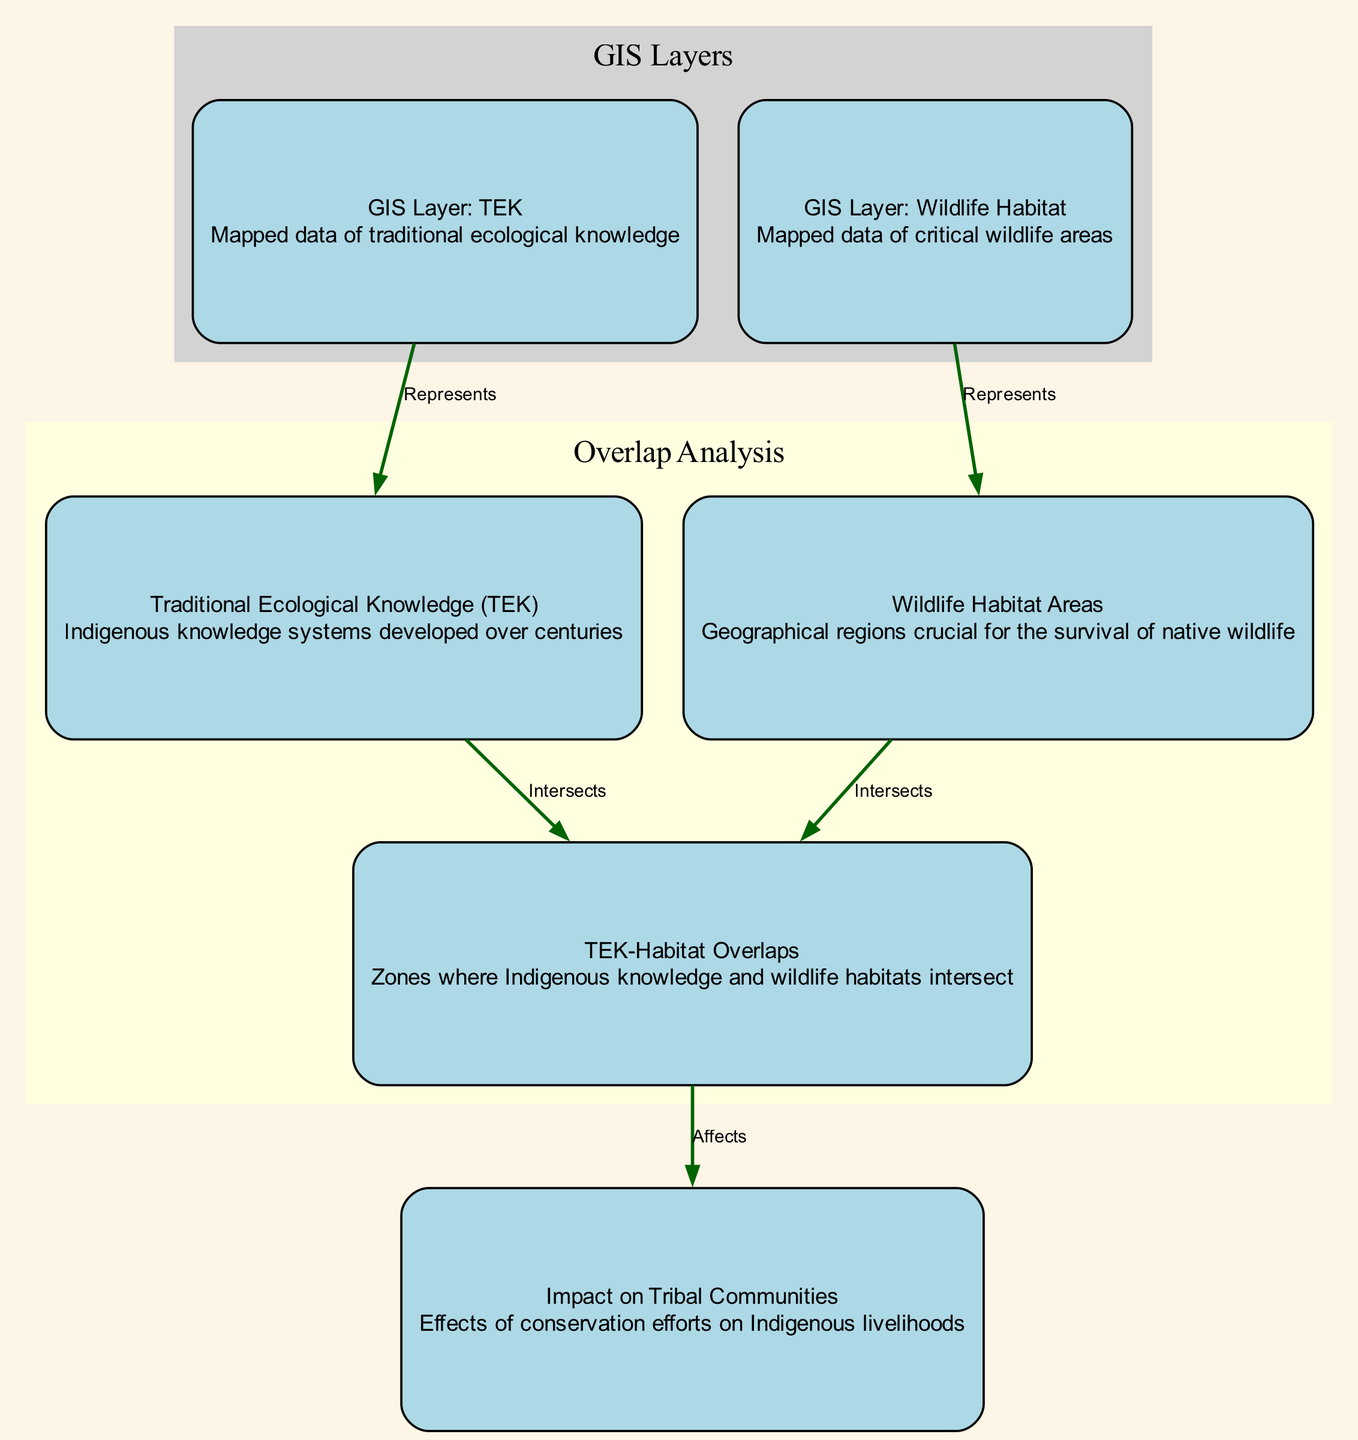What is the total number of nodes in the diagram? The diagram has six distinct nodes: TEK, Wildlife Habitat Areas, TEK-Habitat Overlaps, GIS Layer: TEK, GIS Layer: Wildlife Habitat, and Impact on Tribal Communities. Therefore, the total number of nodes is six.
Answer: 6 What does the TEK node represent? The TEK node represents Traditional Ecological Knowledge, defined as Indigenous knowledge systems developed over centuries.
Answer: Traditional Ecological Knowledge (TEK) Which two nodes intersect to form the TEK-Habitat Overlaps? The two nodes that intersect to form the TEK-Habitat Overlaps are Traditional Ecological Knowledge (TEK) and Wildlife Habitat Areas.
Answer: TEK and Wildlife Habitat Areas How many edges are there in the diagram? By counting the edges listed in the diagram, there are five distinct edges connecting the nodes, showing relationships between them.
Answer: 5 What is the relationship between the TEK-Habitat Overlaps and the Impact on Tribal Communities? The relationship is that the TEK-Habitat Overlaps affects the Impact on Tribal Communities, indicating that the overlapping areas have consequences for Indigenous livelihoods.
Answer: Affects Which GIS layer represents the mapped data of traditional ecological knowledge? The GIS layer that represents the mapped data of traditional ecological knowledge is the GIS Layer: TEK.
Answer: GIS Layer: TEK What color is used to represent the GIS Layers in the diagram? The color used to represent the GIS Layers in the diagram is light grey, as seen in the subgraph designated for GIS layers.
Answer: Light grey How many nodes are connected to the TEK node? The TEK node is connected to two other nodes: the TEK-Habitat Overlaps node and the GIS Layer: TEK node, making for a total of two connections.
Answer: 2 What is the purpose of the GIS Layer: Wildlife Habitat node? The GIS Layer: Wildlife Habitat node represents mapped data of critical wildlife areas, showing the geographical regions essential for wildlife survival.
Answer: Mapped data of critical wildlife areas 